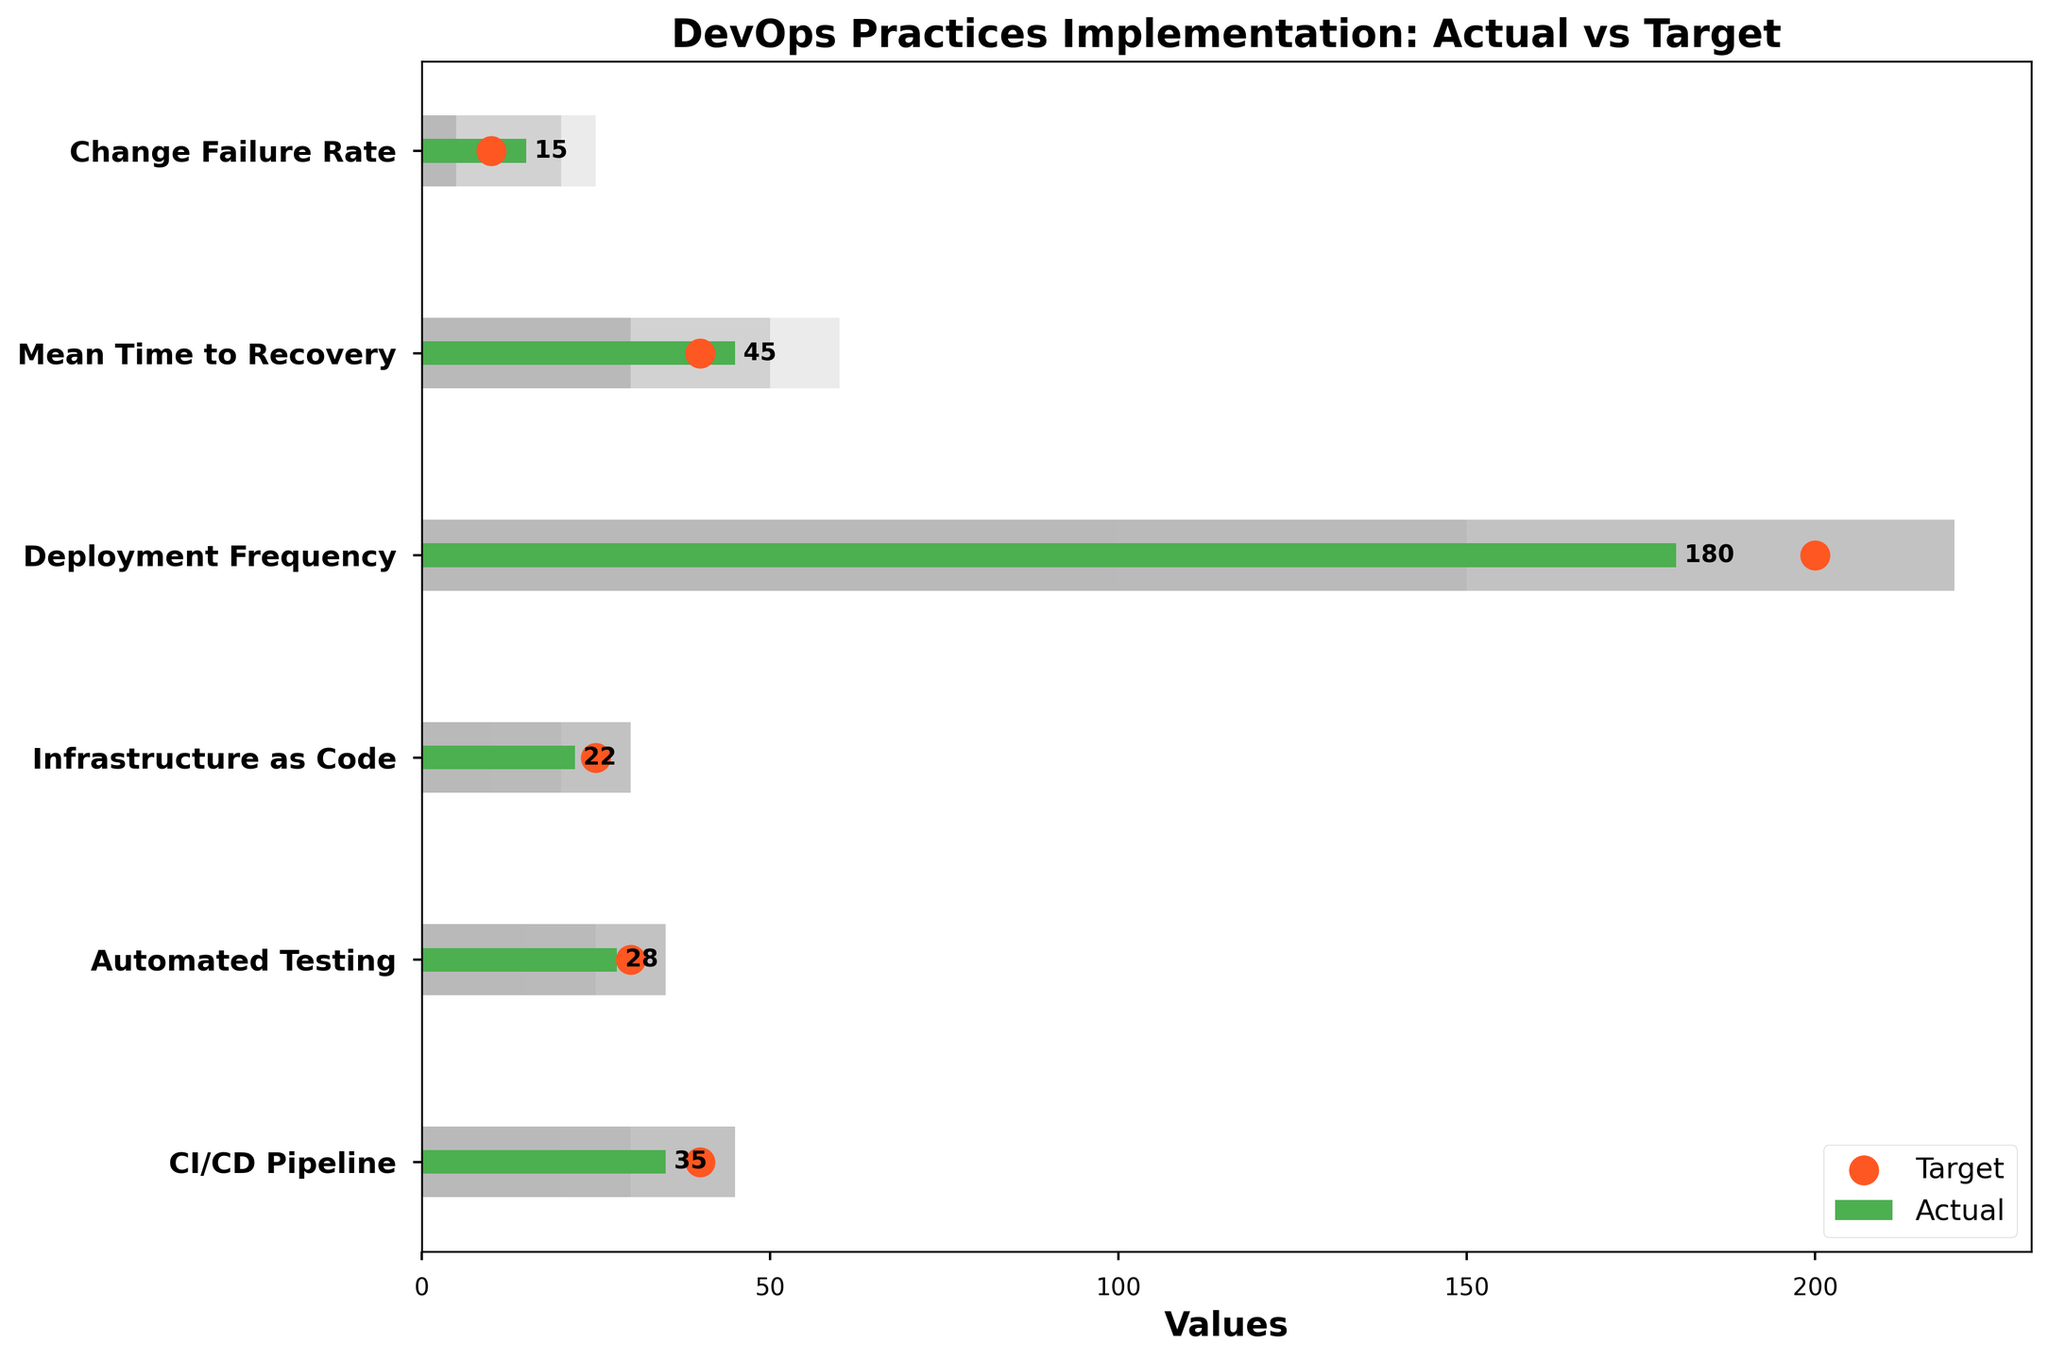What is the title of the chart? The title of the chart can be found at the top. It provides an overview of what the chart is displaying.
Answer: DevOps Practices Implementation: Actual vs Target What is the actual value for CI/CD Pipeline? Look at the bar representing the CI/CD Pipeline and read the numerical value within or next to the bar.
Answer: 35 What is the target value for Mean Time to Recovery? Look for the orange marker on the bar corresponding to Mean Time to Recovery. The number next to the marker is the target value.
Answer: 40 Which category has the highest actual value? Compare all the green bars and identify the one with the longest length. This corresponds to the highest actual value.
Answer: Deployment Frequency How does the actual value of Change Failure Rate compare to its target value? Compare the green bar length of Change Failure Rate to the position of its orange target marker. This shows how the actual value stands relative to the target.
Answer: The actual value (15) is higher than the target value (10) What is the range of acceptable values for Automated Testing? The range encompasses Range1, Range2, and Range3. Read these values for the Automated Testing row.
Answer: 15 to 35 Is the actual value of Deployment Frequency above or below its target? Compare the length of the green bar for Deployment Frequency to the position of its orange target marker.
Answer: Below Which categories have actual values below their targets? For each category, compare the green bar length to the respective orange marker. Identify which bars fall short of the markers.
Answer: CI/CD Pipeline, Automated Testing, Infrastructure as Code, Deployment Frequency What is the difference between the actual and target values for Infrastructure as Code? Subtract the actual value from the target value for the Infrastructure as Code category.
Answer: 3 How many categories have actual values falling within their acceptable ranges? Check if the green bars fall within the shaded ranges (which combine Range1, Range2, and Range3) for each category. Count those that do.
Answer: Four categories (CI/CD Pipeline, Automated Testing, Infrastructure as Code, Deployment Frequency) 